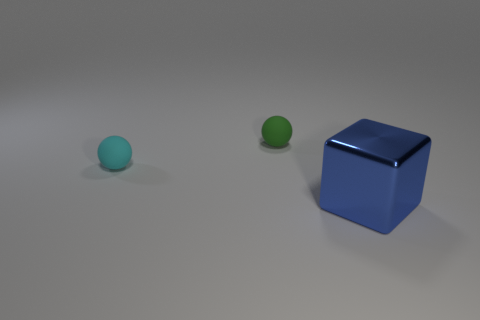How many things are objects behind the large blue block or objects that are left of the big object?
Offer a terse response. 2. Are there any small matte objects on the left side of the thing behind the cyan matte thing?
Offer a very short reply. Yes. The cyan matte object that is the same size as the green matte sphere is what shape?
Give a very brief answer. Sphere. What number of objects are objects on the right side of the small green matte thing or small matte spheres?
Make the answer very short. 3. How many other objects are there of the same material as the blue block?
Your response must be concise. 0. What is the size of the thing that is on the right side of the tiny green object?
Make the answer very short. Large. There is another small thing that is the same material as the green thing; what shape is it?
Your response must be concise. Sphere. Do the small green thing and the large cube that is in front of the tiny green matte object have the same material?
Your answer should be very brief. No. There is a thing that is behind the tiny cyan matte ball; is its shape the same as the tiny cyan rubber object?
Your answer should be very brief. Yes. There is a small green object; does it have the same shape as the tiny thing that is on the left side of the small green matte sphere?
Your response must be concise. Yes. 